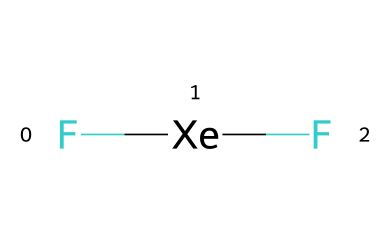What is the chemical formula of the compound? The chemical structure shows two fluorine atoms (F) bonded to one xenon atom (Xe). Thus, the formula is derived from the arrangement and types of constituent atoms.
Answer: XeF2 How many atoms are present in the molecule? The chemical structure indicates one xenon atom and two fluorine atoms, giving a total of three atoms when counted together.
Answer: 3 What type of bonding is present in xenon difluoride? The bonds seen in the structure are covalent bonds between the xenon and the fluorine atoms. Each F atom shares electrons with the Xe atom.
Answer: covalent Is xenon difluoride a polar or nonpolar molecule? To determine polarity, we analyze the shape of the molecule which is bent due to the two lone pairs on xenon, resulting in an uneven charge distribution. Therefore, it is polar.
Answer: polar What hybridization does the xenon atom possess in this molecule? The bonding and lone pairs around the xenon atom indicate that the hybridization is sp3, given it has two fluorine bonding pairs and two lone pairs.
Answer: sp3 What is the relevant oxidation state of xenon in this compound? In xenon difluoride, xenon loses two electrons to bond with two highly electronegative fluorine atoms, resulting in an oxidation state of +2.
Answer: +2 